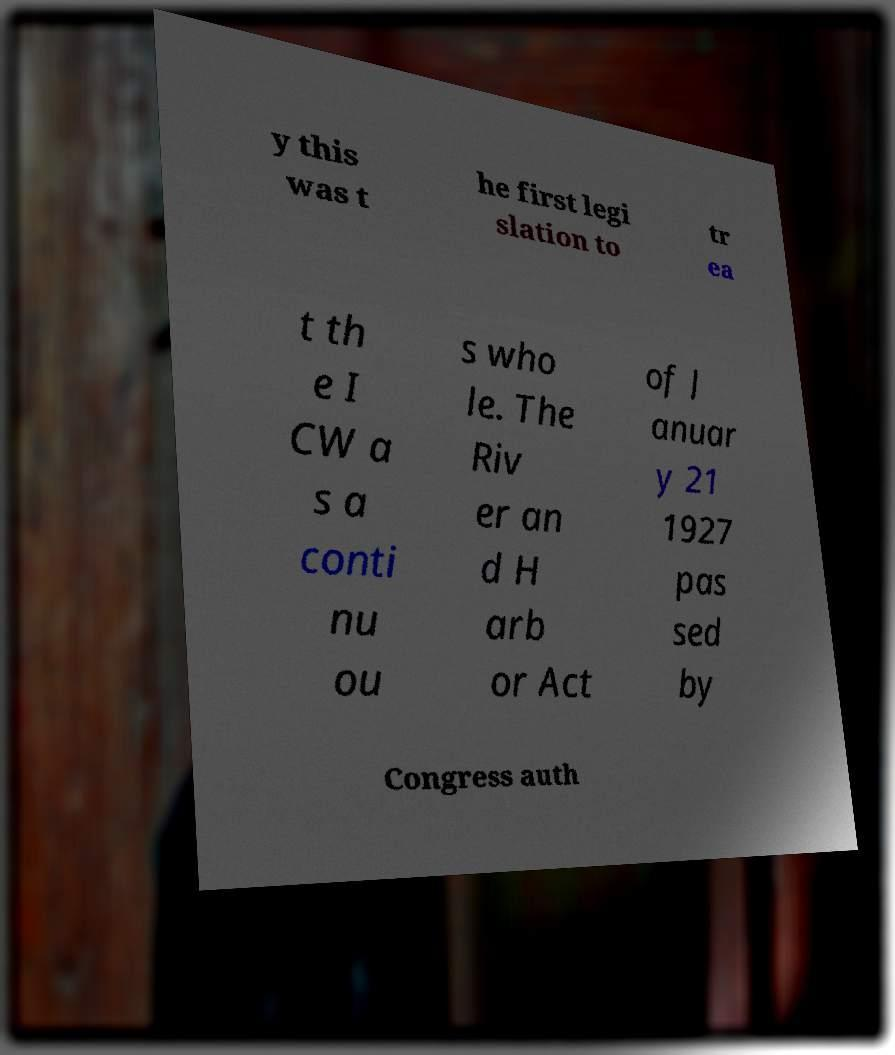Can you accurately transcribe the text from the provided image for me? y this was t he first legi slation to tr ea t th e I CW a s a conti nu ou s who le. The Riv er an d H arb or Act of J anuar y 21 1927 pas sed by Congress auth 